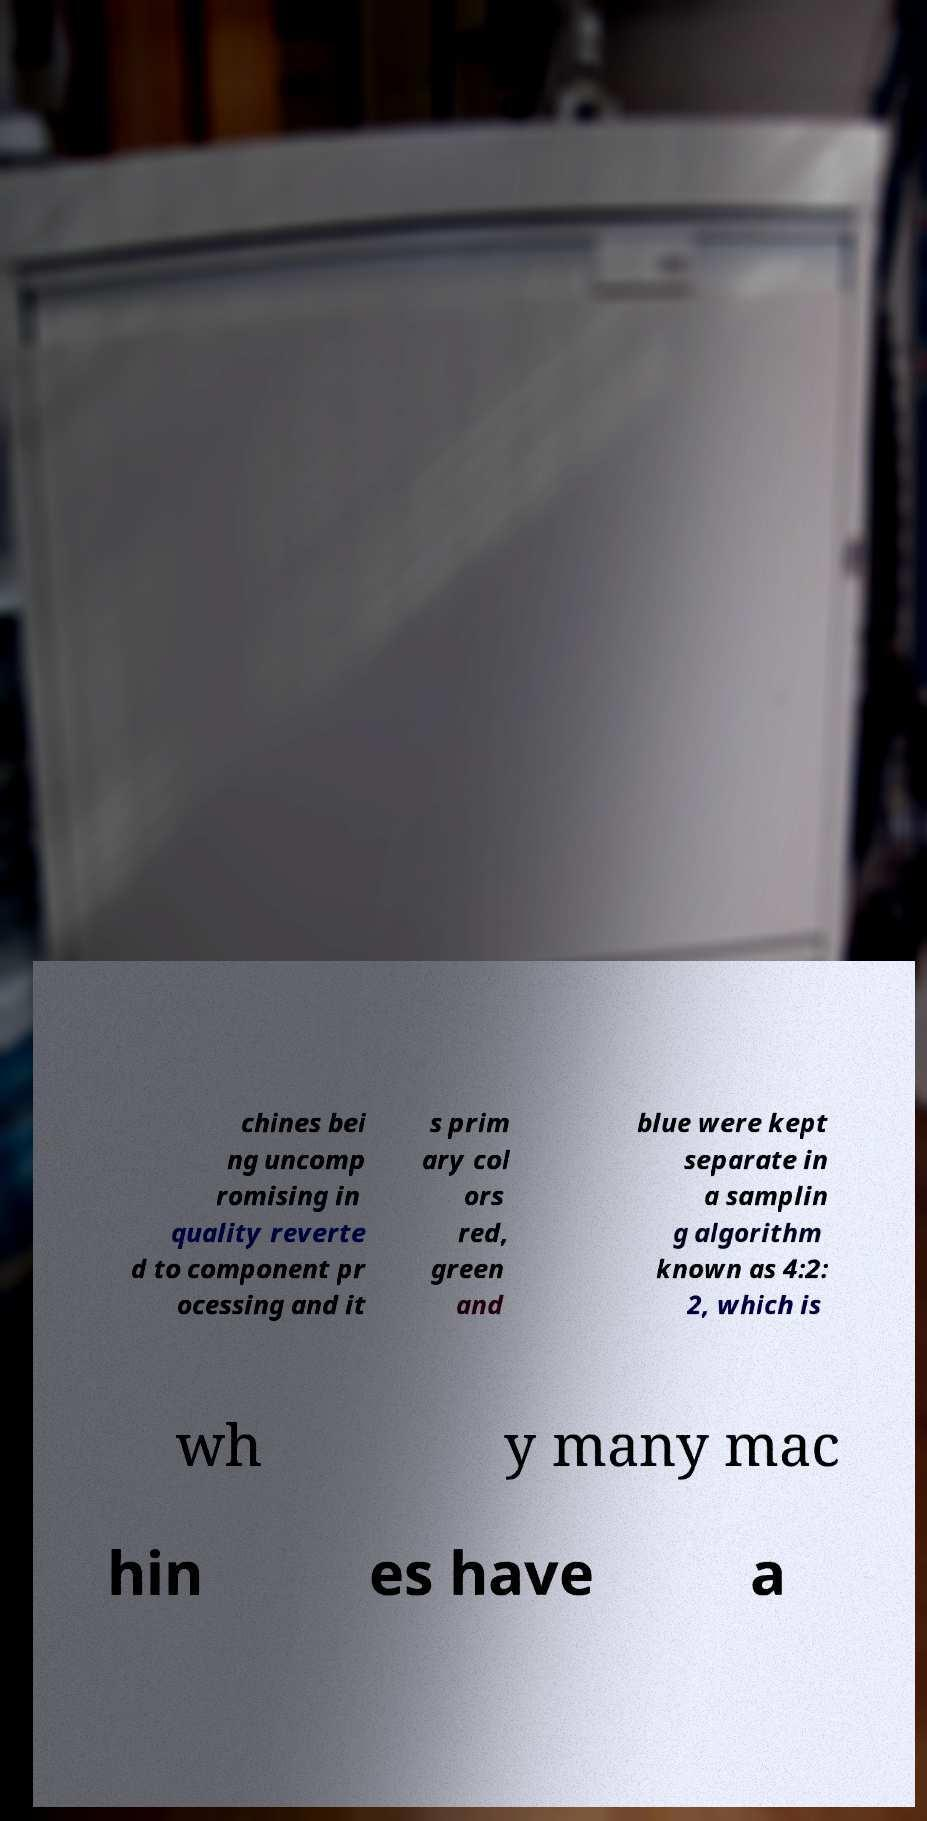What messages or text are displayed in this image? I need them in a readable, typed format. chines bei ng uncomp romising in quality reverte d to component pr ocessing and it s prim ary col ors red, green and blue were kept separate in a samplin g algorithm known as 4:2: 2, which is wh y many mac hin es have a 